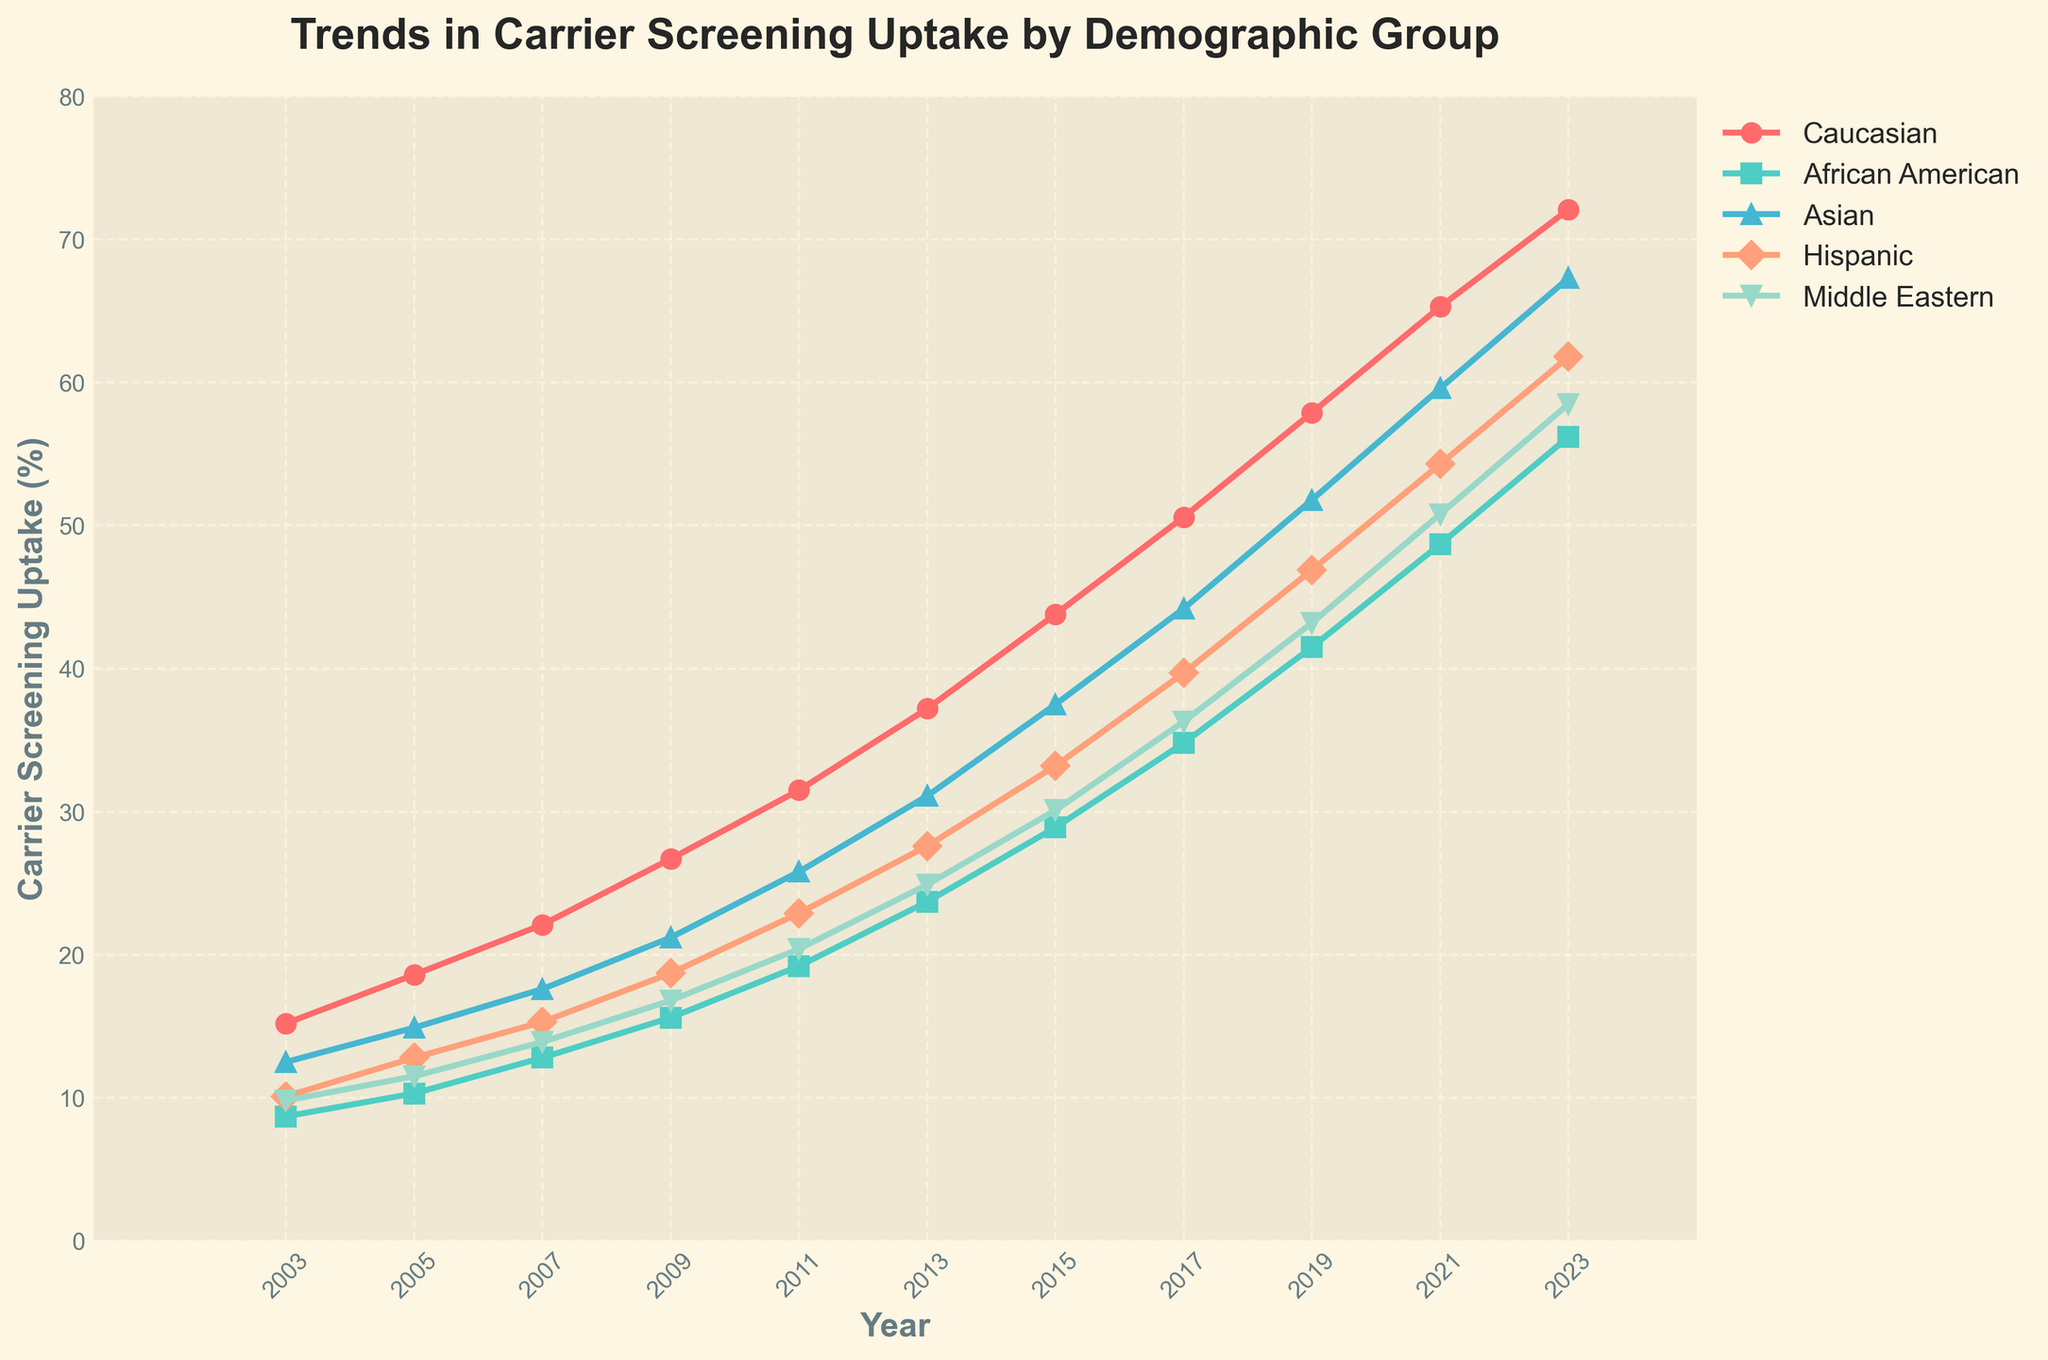Which demographic group had the highest carrier screening uptake in 2023? From the chart, observe the heights of the lines at the year 2023. The line representing the Caucasian demographic is the highest.
Answer: Caucasian How did the carrier screening uptake for the Hispanic demographic group change from 2003 to 2023? Look at the values for the Hispanic group in 2003 and 2023. In 2003, it was 10.1%, while in 2023 it was 61.8%. So the uptake increased by 51.7 percentage points.
Answer: Increased by 51.7 percentage points What was the difference in the carrier screening uptake between the Asian and Middle Eastern demographic groups in 2019? In 2019, the Asian group's uptake was 51.8%, and the Middle Eastern group's uptake was 43.2%. The difference is 51.8% - 43.2% = 8.6%.
Answer: 8.6 percentage points Which demographic group had the highest uptake growth rate from 2003 to 2023? Calculate the differences in uptake from 2003 to 2023 for each demographic group. The group with the highest difference indicates the highest growth rate. The Caucasian group grew from 15.2% to 72.1%, a difference of 56.9%, which is the highest.
Answer: Caucasian What was the average carrier screening uptake for the Middle Eastern demographic between 2003 and 2023? Add up the uptakes for the Middle Eastern demographic for each year and divide by the number of years. Sum: (9.8 + 11.5 + 13.9 + 16.8 + 20.4 + 24.9 + 30.1 + 36.3 + 43.2 + 50.8 + 58.5) = 316.1, then divide by 11 years: 316.1 / 11 ≈ 28.7%.
Answer: 28.7% In which year did the African American demographic group surpass the Hispanic group in carrier screening uptake? Trace both the African American and Hispanic lines on the chart. The African American line crosses the Hispanic line between 2017 and 2019.
Answer: Between 2017 and 2019 Compare the rate of increase in carrier screening uptake between 2009 and 2013 for Caucasian and Asian demographics. For the Caucasian demographic, the increase from 2009 to 2013 is 37.2% - 26.7% = 10.5%. For the Asian demographic, the increase from 2009 to 2013 is 31.1% - 21.2% = 9.9%. So, the Caucasian group had a higher rate of increase by 0.6 percentage points.
Answer: Caucasian by 0.6 percentage points 